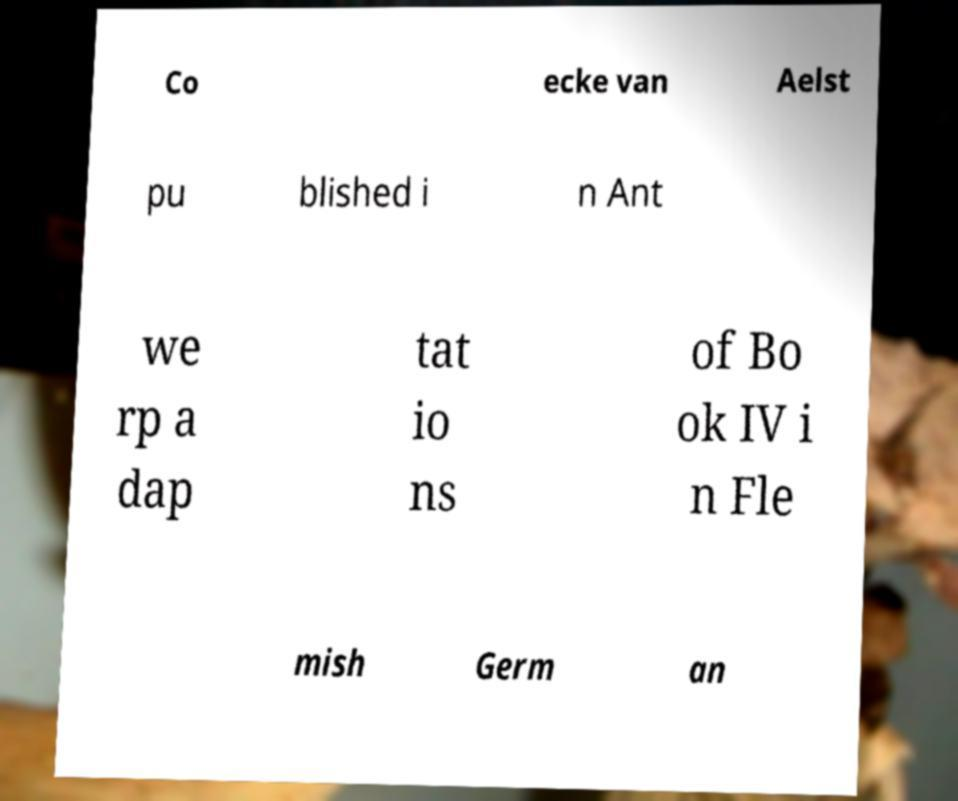Could you assist in decoding the text presented in this image and type it out clearly? Co ecke van Aelst pu blished i n Ant we rp a dap tat io ns of Bo ok IV i n Fle mish Germ an 